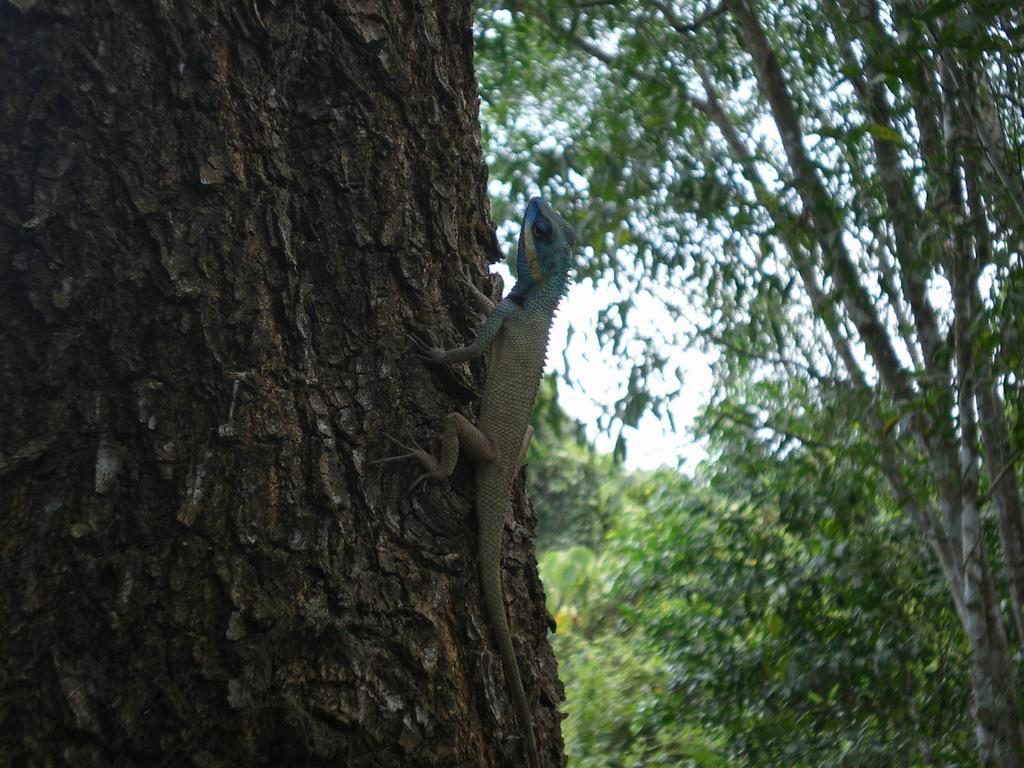Could you give a brief overview of what you see in this image? In this picture we can see a reptile on the tree, in the background we can find few more trees. 